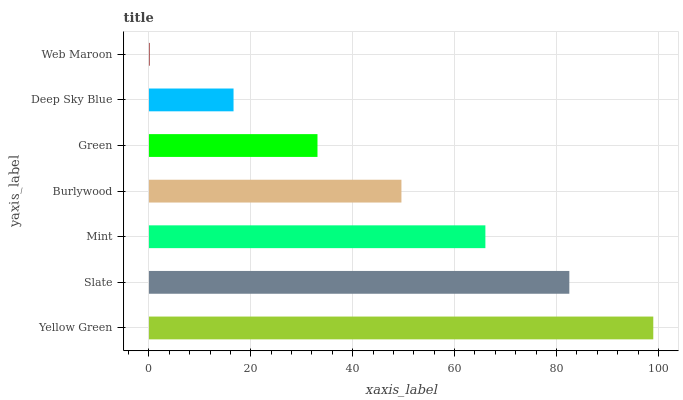Is Web Maroon the minimum?
Answer yes or no. Yes. Is Yellow Green the maximum?
Answer yes or no. Yes. Is Slate the minimum?
Answer yes or no. No. Is Slate the maximum?
Answer yes or no. No. Is Yellow Green greater than Slate?
Answer yes or no. Yes. Is Slate less than Yellow Green?
Answer yes or no. Yes. Is Slate greater than Yellow Green?
Answer yes or no. No. Is Yellow Green less than Slate?
Answer yes or no. No. Is Burlywood the high median?
Answer yes or no. Yes. Is Burlywood the low median?
Answer yes or no. Yes. Is Green the high median?
Answer yes or no. No. Is Deep Sky Blue the low median?
Answer yes or no. No. 